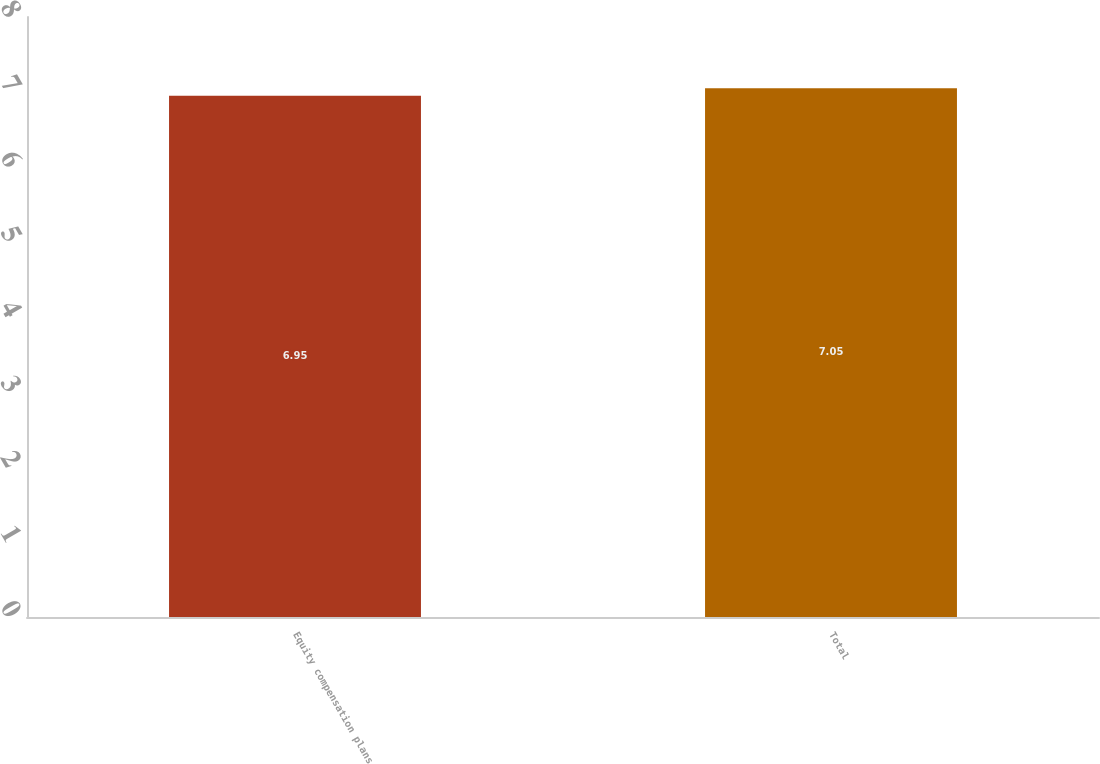<chart> <loc_0><loc_0><loc_500><loc_500><bar_chart><fcel>Equity compensation plans<fcel>Total<nl><fcel>6.95<fcel>7.05<nl></chart> 